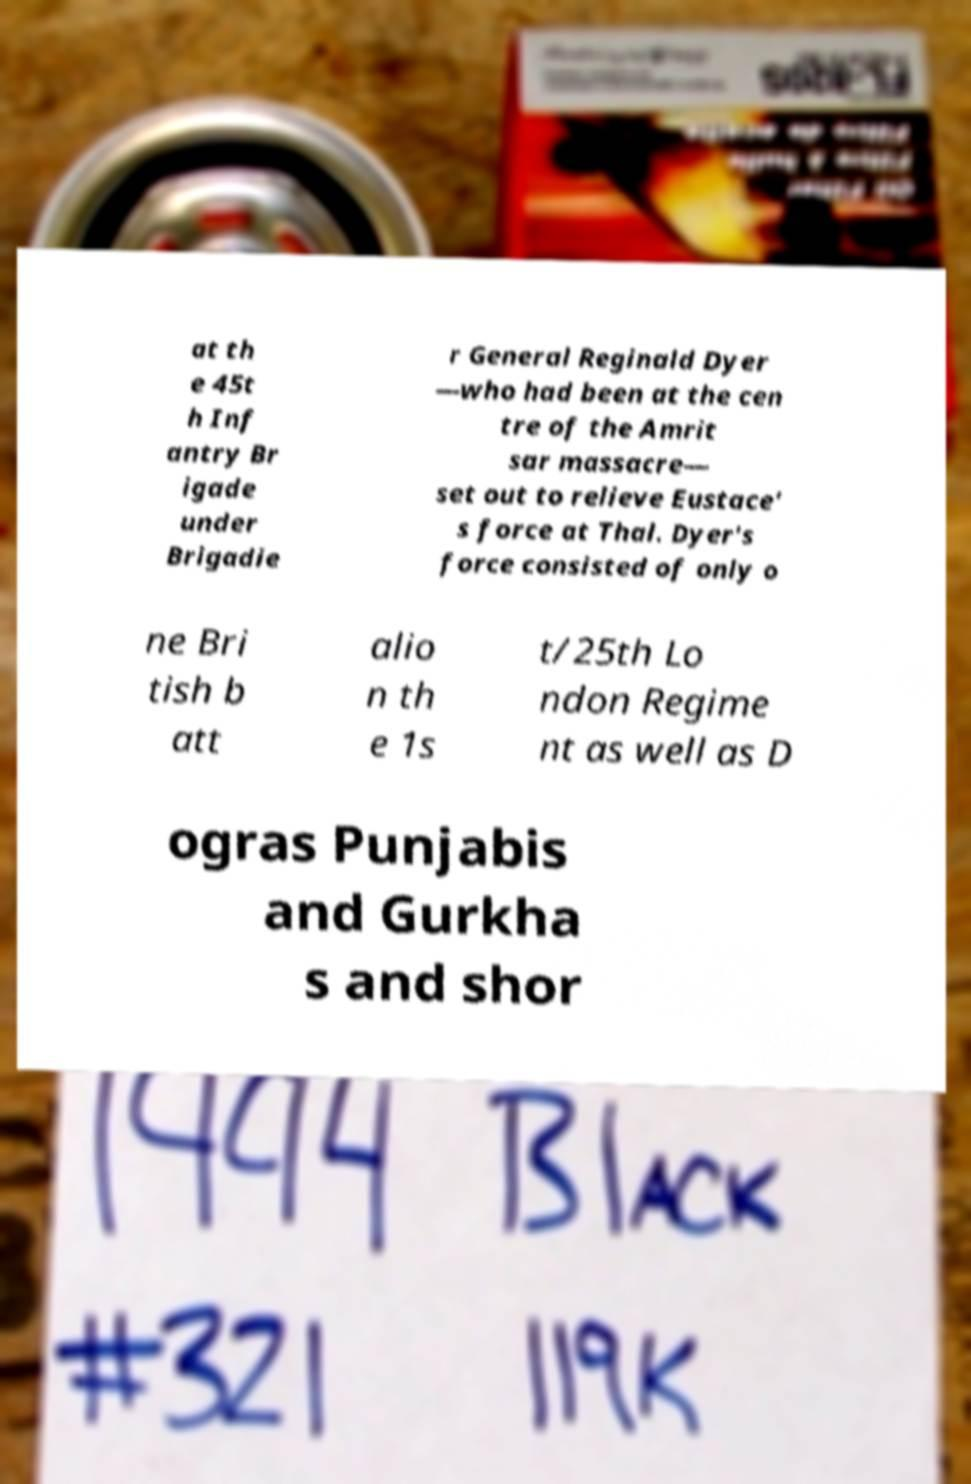Can you read and provide the text displayed in the image?This photo seems to have some interesting text. Can you extract and type it out for me? at th e 45t h Inf antry Br igade under Brigadie r General Reginald Dyer —who had been at the cen tre of the Amrit sar massacre— set out to relieve Eustace' s force at Thal. Dyer's force consisted of only o ne Bri tish b att alio n th e 1s t/25th Lo ndon Regime nt as well as D ogras Punjabis and Gurkha s and shor 